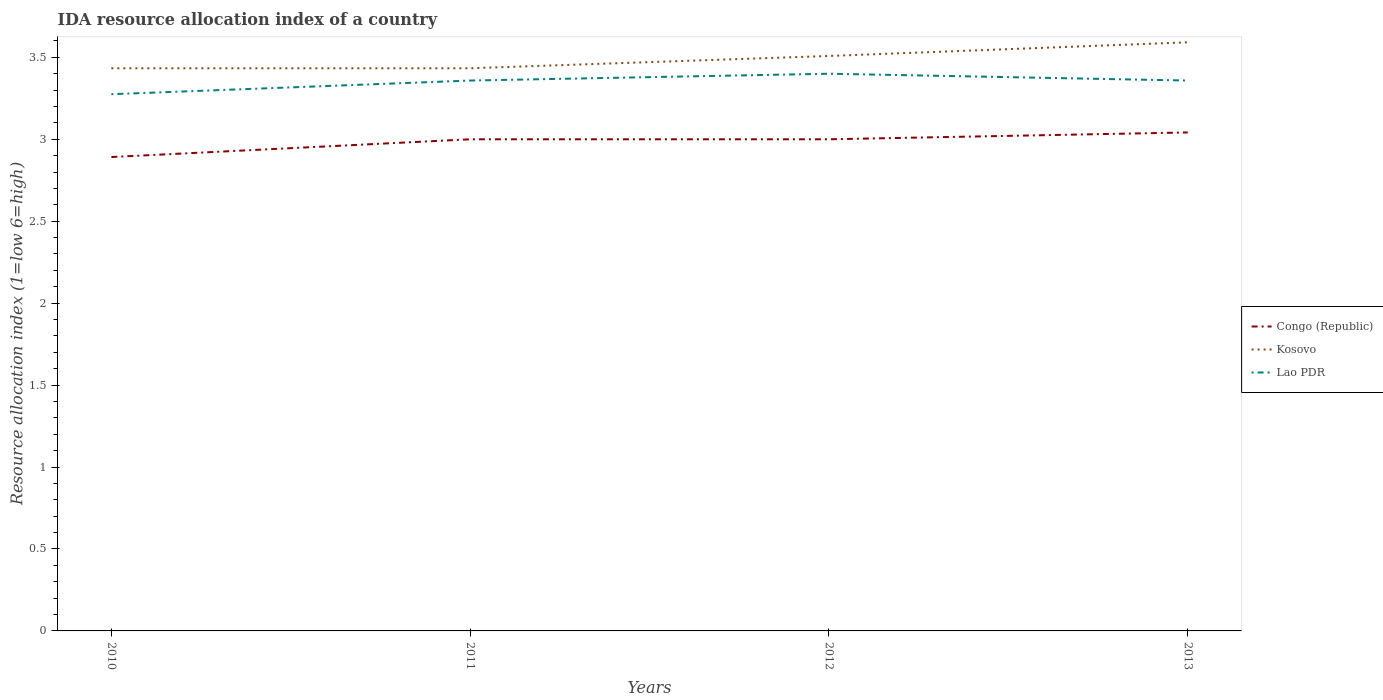How many different coloured lines are there?
Make the answer very short. 3. Does the line corresponding to Kosovo intersect with the line corresponding to Congo (Republic)?
Keep it short and to the point. No. Is the number of lines equal to the number of legend labels?
Offer a very short reply. Yes. Across all years, what is the maximum IDA resource allocation index in Lao PDR?
Provide a short and direct response. 3.27. In which year was the IDA resource allocation index in Congo (Republic) maximum?
Offer a very short reply. 2010. What is the total IDA resource allocation index in Lao PDR in the graph?
Provide a succinct answer. -0.08. What is the difference between the highest and the second highest IDA resource allocation index in Kosovo?
Provide a succinct answer. 0.16. How many lines are there?
Your answer should be very brief. 3. What is the difference between two consecutive major ticks on the Y-axis?
Provide a succinct answer. 0.5. Does the graph contain any zero values?
Offer a very short reply. No. Where does the legend appear in the graph?
Offer a very short reply. Center right. How many legend labels are there?
Give a very brief answer. 3. How are the legend labels stacked?
Make the answer very short. Vertical. What is the title of the graph?
Ensure brevity in your answer.  IDA resource allocation index of a country. What is the label or title of the Y-axis?
Your answer should be compact. Resource allocation index (1=low 6=high). What is the Resource allocation index (1=low 6=high) in Congo (Republic) in 2010?
Make the answer very short. 2.89. What is the Resource allocation index (1=low 6=high) in Kosovo in 2010?
Ensure brevity in your answer.  3.43. What is the Resource allocation index (1=low 6=high) of Lao PDR in 2010?
Provide a succinct answer. 3.27. What is the Resource allocation index (1=low 6=high) of Kosovo in 2011?
Your response must be concise. 3.43. What is the Resource allocation index (1=low 6=high) in Lao PDR in 2011?
Make the answer very short. 3.36. What is the Resource allocation index (1=low 6=high) of Kosovo in 2012?
Give a very brief answer. 3.51. What is the Resource allocation index (1=low 6=high) of Lao PDR in 2012?
Your answer should be very brief. 3.4. What is the Resource allocation index (1=low 6=high) of Congo (Republic) in 2013?
Offer a very short reply. 3.04. What is the Resource allocation index (1=low 6=high) in Kosovo in 2013?
Ensure brevity in your answer.  3.59. What is the Resource allocation index (1=low 6=high) of Lao PDR in 2013?
Offer a very short reply. 3.36. Across all years, what is the maximum Resource allocation index (1=low 6=high) in Congo (Republic)?
Your answer should be compact. 3.04. Across all years, what is the maximum Resource allocation index (1=low 6=high) of Kosovo?
Provide a succinct answer. 3.59. Across all years, what is the minimum Resource allocation index (1=low 6=high) in Congo (Republic)?
Make the answer very short. 2.89. Across all years, what is the minimum Resource allocation index (1=low 6=high) in Kosovo?
Keep it short and to the point. 3.43. Across all years, what is the minimum Resource allocation index (1=low 6=high) of Lao PDR?
Keep it short and to the point. 3.27. What is the total Resource allocation index (1=low 6=high) of Congo (Republic) in the graph?
Ensure brevity in your answer.  11.93. What is the total Resource allocation index (1=low 6=high) of Kosovo in the graph?
Keep it short and to the point. 13.97. What is the total Resource allocation index (1=low 6=high) of Lao PDR in the graph?
Offer a very short reply. 13.39. What is the difference between the Resource allocation index (1=low 6=high) of Congo (Republic) in 2010 and that in 2011?
Provide a short and direct response. -0.11. What is the difference between the Resource allocation index (1=low 6=high) in Kosovo in 2010 and that in 2011?
Your answer should be compact. 0. What is the difference between the Resource allocation index (1=low 6=high) of Lao PDR in 2010 and that in 2011?
Give a very brief answer. -0.08. What is the difference between the Resource allocation index (1=low 6=high) of Congo (Republic) in 2010 and that in 2012?
Make the answer very short. -0.11. What is the difference between the Resource allocation index (1=low 6=high) in Kosovo in 2010 and that in 2012?
Your response must be concise. -0.07. What is the difference between the Resource allocation index (1=low 6=high) of Lao PDR in 2010 and that in 2012?
Your answer should be very brief. -0.12. What is the difference between the Resource allocation index (1=low 6=high) in Kosovo in 2010 and that in 2013?
Provide a succinct answer. -0.16. What is the difference between the Resource allocation index (1=low 6=high) in Lao PDR in 2010 and that in 2013?
Your response must be concise. -0.08. What is the difference between the Resource allocation index (1=low 6=high) in Kosovo in 2011 and that in 2012?
Your answer should be very brief. -0.07. What is the difference between the Resource allocation index (1=low 6=high) of Lao PDR in 2011 and that in 2012?
Ensure brevity in your answer.  -0.04. What is the difference between the Resource allocation index (1=low 6=high) in Congo (Republic) in 2011 and that in 2013?
Offer a very short reply. -0.04. What is the difference between the Resource allocation index (1=low 6=high) of Kosovo in 2011 and that in 2013?
Provide a succinct answer. -0.16. What is the difference between the Resource allocation index (1=low 6=high) in Lao PDR in 2011 and that in 2013?
Your answer should be very brief. 0. What is the difference between the Resource allocation index (1=low 6=high) of Congo (Republic) in 2012 and that in 2013?
Ensure brevity in your answer.  -0.04. What is the difference between the Resource allocation index (1=low 6=high) in Kosovo in 2012 and that in 2013?
Make the answer very short. -0.08. What is the difference between the Resource allocation index (1=low 6=high) in Lao PDR in 2012 and that in 2013?
Keep it short and to the point. 0.04. What is the difference between the Resource allocation index (1=low 6=high) of Congo (Republic) in 2010 and the Resource allocation index (1=low 6=high) of Kosovo in 2011?
Your answer should be compact. -0.54. What is the difference between the Resource allocation index (1=low 6=high) in Congo (Republic) in 2010 and the Resource allocation index (1=low 6=high) in Lao PDR in 2011?
Your answer should be compact. -0.47. What is the difference between the Resource allocation index (1=low 6=high) in Kosovo in 2010 and the Resource allocation index (1=low 6=high) in Lao PDR in 2011?
Your answer should be very brief. 0.07. What is the difference between the Resource allocation index (1=low 6=high) in Congo (Republic) in 2010 and the Resource allocation index (1=low 6=high) in Kosovo in 2012?
Your answer should be compact. -0.62. What is the difference between the Resource allocation index (1=low 6=high) of Congo (Republic) in 2010 and the Resource allocation index (1=low 6=high) of Lao PDR in 2012?
Give a very brief answer. -0.51. What is the difference between the Resource allocation index (1=low 6=high) of Congo (Republic) in 2010 and the Resource allocation index (1=low 6=high) of Kosovo in 2013?
Offer a terse response. -0.7. What is the difference between the Resource allocation index (1=low 6=high) of Congo (Republic) in 2010 and the Resource allocation index (1=low 6=high) of Lao PDR in 2013?
Keep it short and to the point. -0.47. What is the difference between the Resource allocation index (1=low 6=high) of Kosovo in 2010 and the Resource allocation index (1=low 6=high) of Lao PDR in 2013?
Ensure brevity in your answer.  0.07. What is the difference between the Resource allocation index (1=low 6=high) in Congo (Republic) in 2011 and the Resource allocation index (1=low 6=high) in Kosovo in 2012?
Your answer should be very brief. -0.51. What is the difference between the Resource allocation index (1=low 6=high) in Congo (Republic) in 2011 and the Resource allocation index (1=low 6=high) in Lao PDR in 2012?
Your answer should be compact. -0.4. What is the difference between the Resource allocation index (1=low 6=high) in Congo (Republic) in 2011 and the Resource allocation index (1=low 6=high) in Kosovo in 2013?
Provide a short and direct response. -0.59. What is the difference between the Resource allocation index (1=low 6=high) in Congo (Republic) in 2011 and the Resource allocation index (1=low 6=high) in Lao PDR in 2013?
Keep it short and to the point. -0.36. What is the difference between the Resource allocation index (1=low 6=high) of Kosovo in 2011 and the Resource allocation index (1=low 6=high) of Lao PDR in 2013?
Ensure brevity in your answer.  0.07. What is the difference between the Resource allocation index (1=low 6=high) in Congo (Republic) in 2012 and the Resource allocation index (1=low 6=high) in Kosovo in 2013?
Keep it short and to the point. -0.59. What is the difference between the Resource allocation index (1=low 6=high) of Congo (Republic) in 2012 and the Resource allocation index (1=low 6=high) of Lao PDR in 2013?
Keep it short and to the point. -0.36. What is the average Resource allocation index (1=low 6=high) of Congo (Republic) per year?
Offer a very short reply. 2.98. What is the average Resource allocation index (1=low 6=high) of Kosovo per year?
Provide a short and direct response. 3.49. What is the average Resource allocation index (1=low 6=high) of Lao PDR per year?
Your response must be concise. 3.35. In the year 2010, what is the difference between the Resource allocation index (1=low 6=high) in Congo (Republic) and Resource allocation index (1=low 6=high) in Kosovo?
Provide a succinct answer. -0.54. In the year 2010, what is the difference between the Resource allocation index (1=low 6=high) of Congo (Republic) and Resource allocation index (1=low 6=high) of Lao PDR?
Provide a succinct answer. -0.38. In the year 2010, what is the difference between the Resource allocation index (1=low 6=high) of Kosovo and Resource allocation index (1=low 6=high) of Lao PDR?
Make the answer very short. 0.16. In the year 2011, what is the difference between the Resource allocation index (1=low 6=high) in Congo (Republic) and Resource allocation index (1=low 6=high) in Kosovo?
Offer a very short reply. -0.43. In the year 2011, what is the difference between the Resource allocation index (1=low 6=high) of Congo (Republic) and Resource allocation index (1=low 6=high) of Lao PDR?
Keep it short and to the point. -0.36. In the year 2011, what is the difference between the Resource allocation index (1=low 6=high) of Kosovo and Resource allocation index (1=low 6=high) of Lao PDR?
Provide a short and direct response. 0.07. In the year 2012, what is the difference between the Resource allocation index (1=low 6=high) of Congo (Republic) and Resource allocation index (1=low 6=high) of Kosovo?
Offer a very short reply. -0.51. In the year 2012, what is the difference between the Resource allocation index (1=low 6=high) in Congo (Republic) and Resource allocation index (1=low 6=high) in Lao PDR?
Your answer should be very brief. -0.4. In the year 2012, what is the difference between the Resource allocation index (1=low 6=high) of Kosovo and Resource allocation index (1=low 6=high) of Lao PDR?
Make the answer very short. 0.11. In the year 2013, what is the difference between the Resource allocation index (1=low 6=high) of Congo (Republic) and Resource allocation index (1=low 6=high) of Kosovo?
Provide a succinct answer. -0.55. In the year 2013, what is the difference between the Resource allocation index (1=low 6=high) of Congo (Republic) and Resource allocation index (1=low 6=high) of Lao PDR?
Your response must be concise. -0.32. In the year 2013, what is the difference between the Resource allocation index (1=low 6=high) in Kosovo and Resource allocation index (1=low 6=high) in Lao PDR?
Your response must be concise. 0.23. What is the ratio of the Resource allocation index (1=low 6=high) of Congo (Republic) in 2010 to that in 2011?
Keep it short and to the point. 0.96. What is the ratio of the Resource allocation index (1=low 6=high) of Lao PDR in 2010 to that in 2011?
Offer a terse response. 0.98. What is the ratio of the Resource allocation index (1=low 6=high) of Congo (Republic) in 2010 to that in 2012?
Keep it short and to the point. 0.96. What is the ratio of the Resource allocation index (1=low 6=high) of Kosovo in 2010 to that in 2012?
Your answer should be very brief. 0.98. What is the ratio of the Resource allocation index (1=low 6=high) of Lao PDR in 2010 to that in 2012?
Your answer should be very brief. 0.96. What is the ratio of the Resource allocation index (1=low 6=high) in Congo (Republic) in 2010 to that in 2013?
Provide a succinct answer. 0.95. What is the ratio of the Resource allocation index (1=low 6=high) of Kosovo in 2010 to that in 2013?
Ensure brevity in your answer.  0.96. What is the ratio of the Resource allocation index (1=low 6=high) in Lao PDR in 2010 to that in 2013?
Your answer should be compact. 0.98. What is the ratio of the Resource allocation index (1=low 6=high) of Kosovo in 2011 to that in 2012?
Provide a short and direct response. 0.98. What is the ratio of the Resource allocation index (1=low 6=high) of Congo (Republic) in 2011 to that in 2013?
Your response must be concise. 0.99. What is the ratio of the Resource allocation index (1=low 6=high) in Kosovo in 2011 to that in 2013?
Keep it short and to the point. 0.96. What is the ratio of the Resource allocation index (1=low 6=high) in Congo (Republic) in 2012 to that in 2013?
Your answer should be very brief. 0.99. What is the ratio of the Resource allocation index (1=low 6=high) in Kosovo in 2012 to that in 2013?
Offer a terse response. 0.98. What is the ratio of the Resource allocation index (1=low 6=high) of Lao PDR in 2012 to that in 2013?
Your answer should be very brief. 1.01. What is the difference between the highest and the second highest Resource allocation index (1=low 6=high) of Congo (Republic)?
Your response must be concise. 0.04. What is the difference between the highest and the second highest Resource allocation index (1=low 6=high) in Kosovo?
Your answer should be compact. 0.08. What is the difference between the highest and the second highest Resource allocation index (1=low 6=high) of Lao PDR?
Provide a short and direct response. 0.04. What is the difference between the highest and the lowest Resource allocation index (1=low 6=high) of Kosovo?
Make the answer very short. 0.16. 